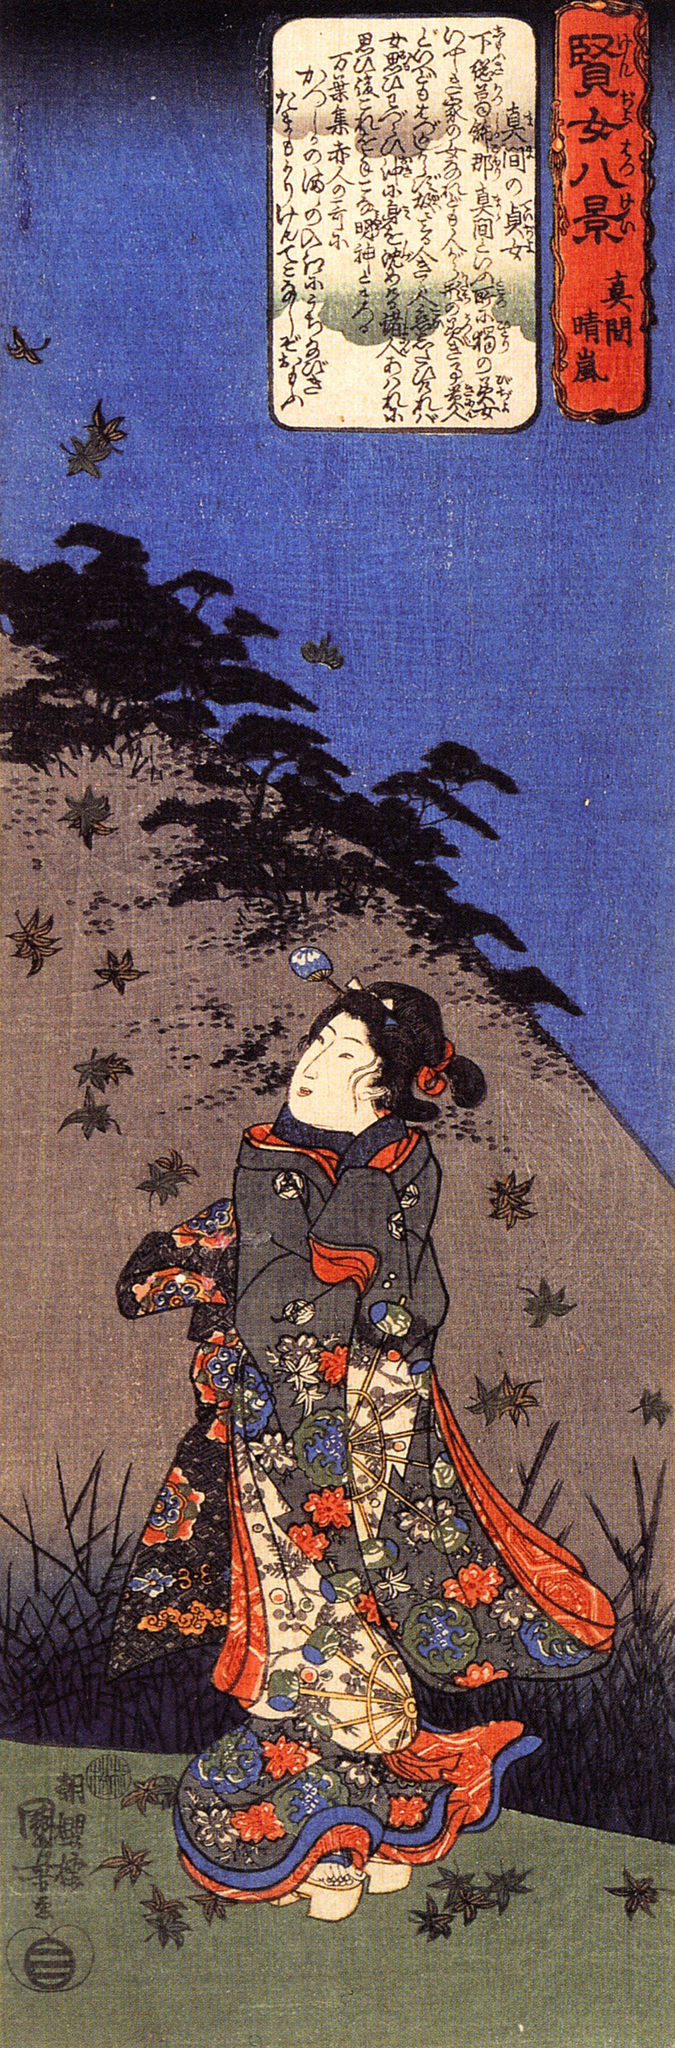How might this image be interpreted in a contemporary context? In a contemporary context, this image could be seen as a reflection on the enduring allure of nature and tradition. The vibrant kimono represents a cultural heritage that has been preserved and cherished through generations. The woman's serene gaze and the natural elements around her can evoke a sense of mindfulness and a longing for the tranquility that is often sought in today's fast-paced world. Additionally, viewers might interpret the image as an invitation to reconnect with nature, appreciate the transient beauty of life, and find balance amidst the chaos. This timeless piece stands as a testament to the enduring relevance of art in bridging past and present emotions and experiences. 